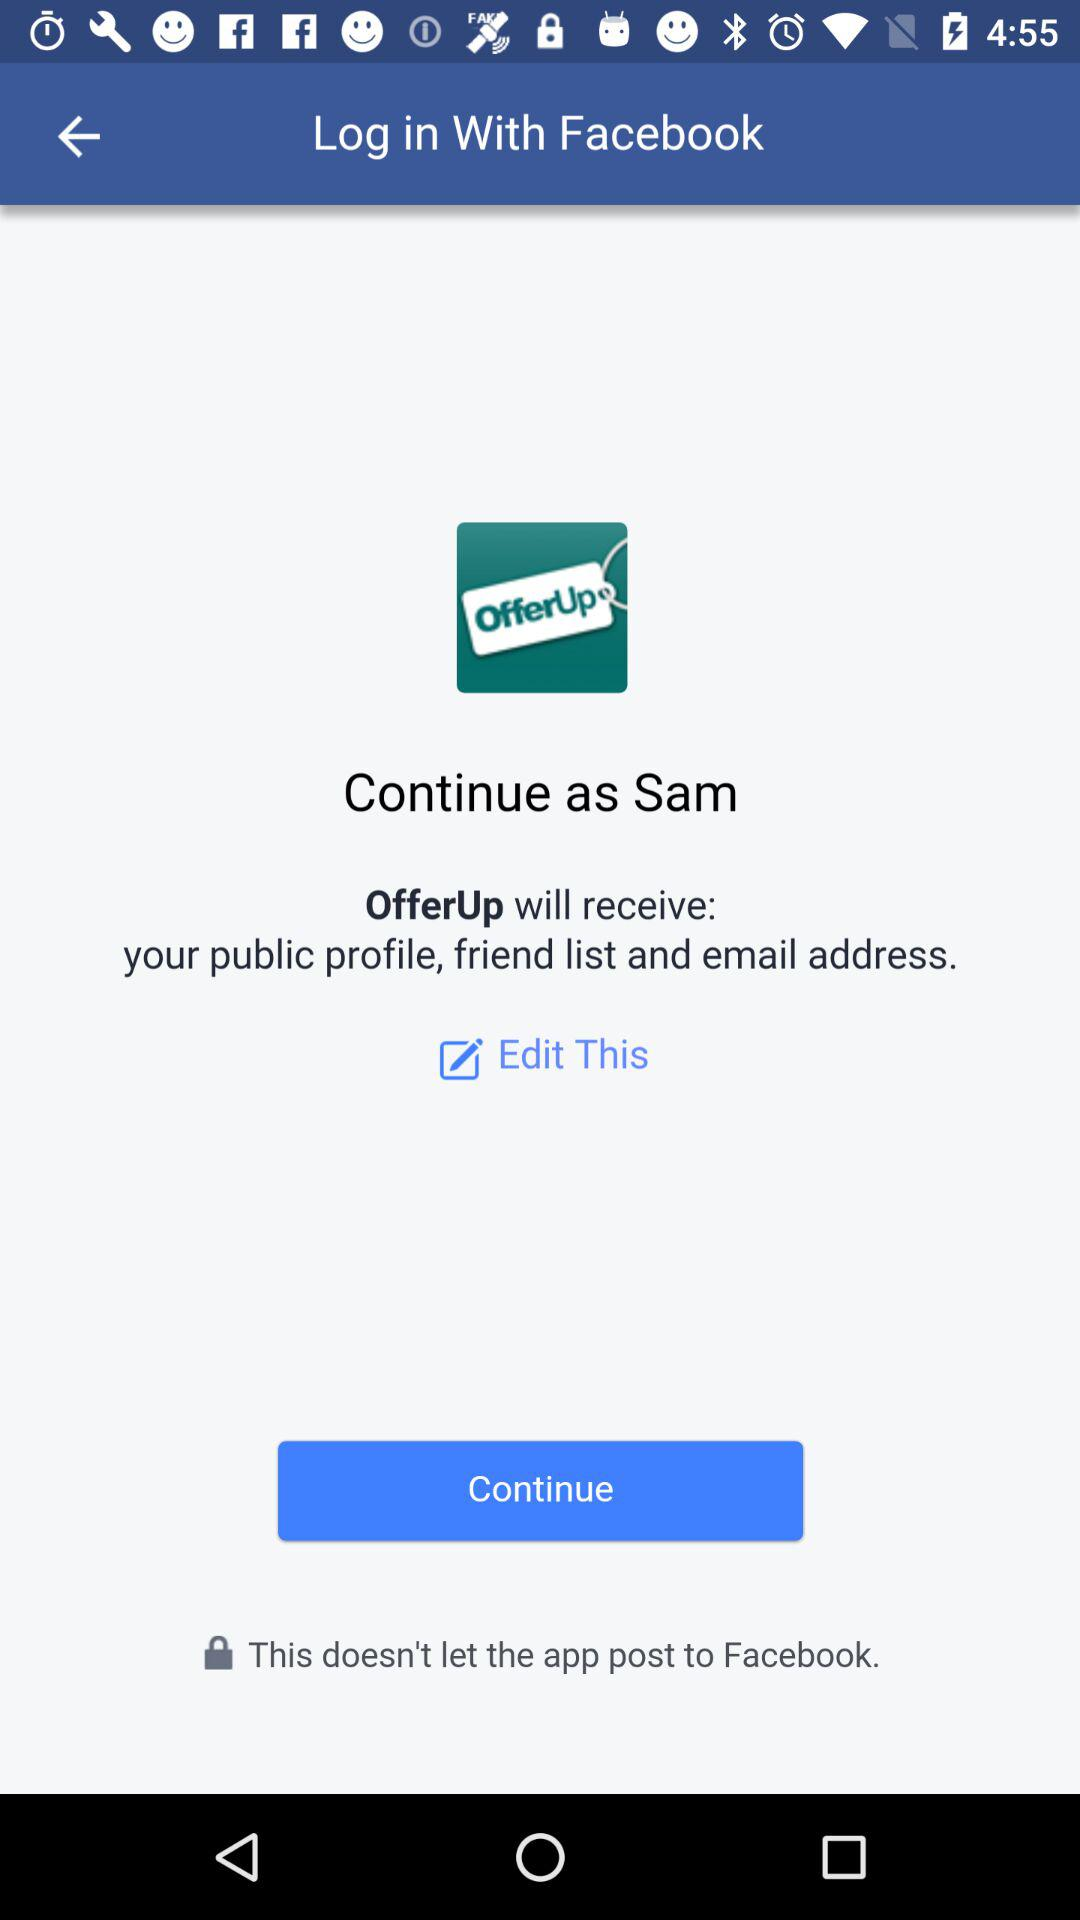What is the name of the user? The name of the user is Sam. 